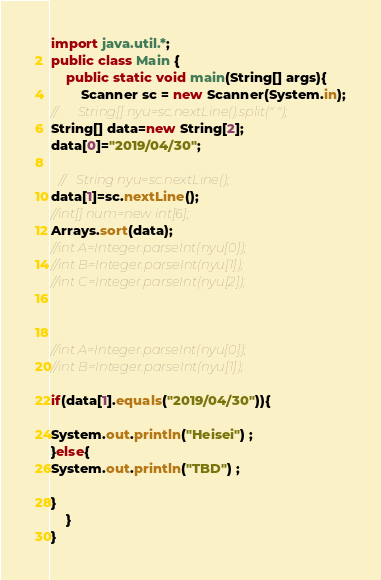<code> <loc_0><loc_0><loc_500><loc_500><_Java_>
import java.util.*;
public class Main {
	public static void main(String[] args){
		Scanner sc = new Scanner(System.in);
//      String[] nyu=sc.nextLine().split(" ");
String[] data=new String[2];
data[0]="2019/04/30";

  //   String nyu=sc.nextLine();
data[1]=sc.nextLine();
//int[] num=new int[6];
Arrays.sort(data);
//int A=Integer.parseInt(nyu[0]);
//int B=Integer.parseInt(nyu[1]);
//int C=Integer.parseInt(nyu[2]);



//int A=Integer.parseInt(nyu[0]);
//int B=Integer.parseInt(nyu[1]);

if(data[1].equals("2019/04/30")){

System.out.println("Heisei") ;
}else{
System.out.println("TBD") ;

}
	}
}</code> 